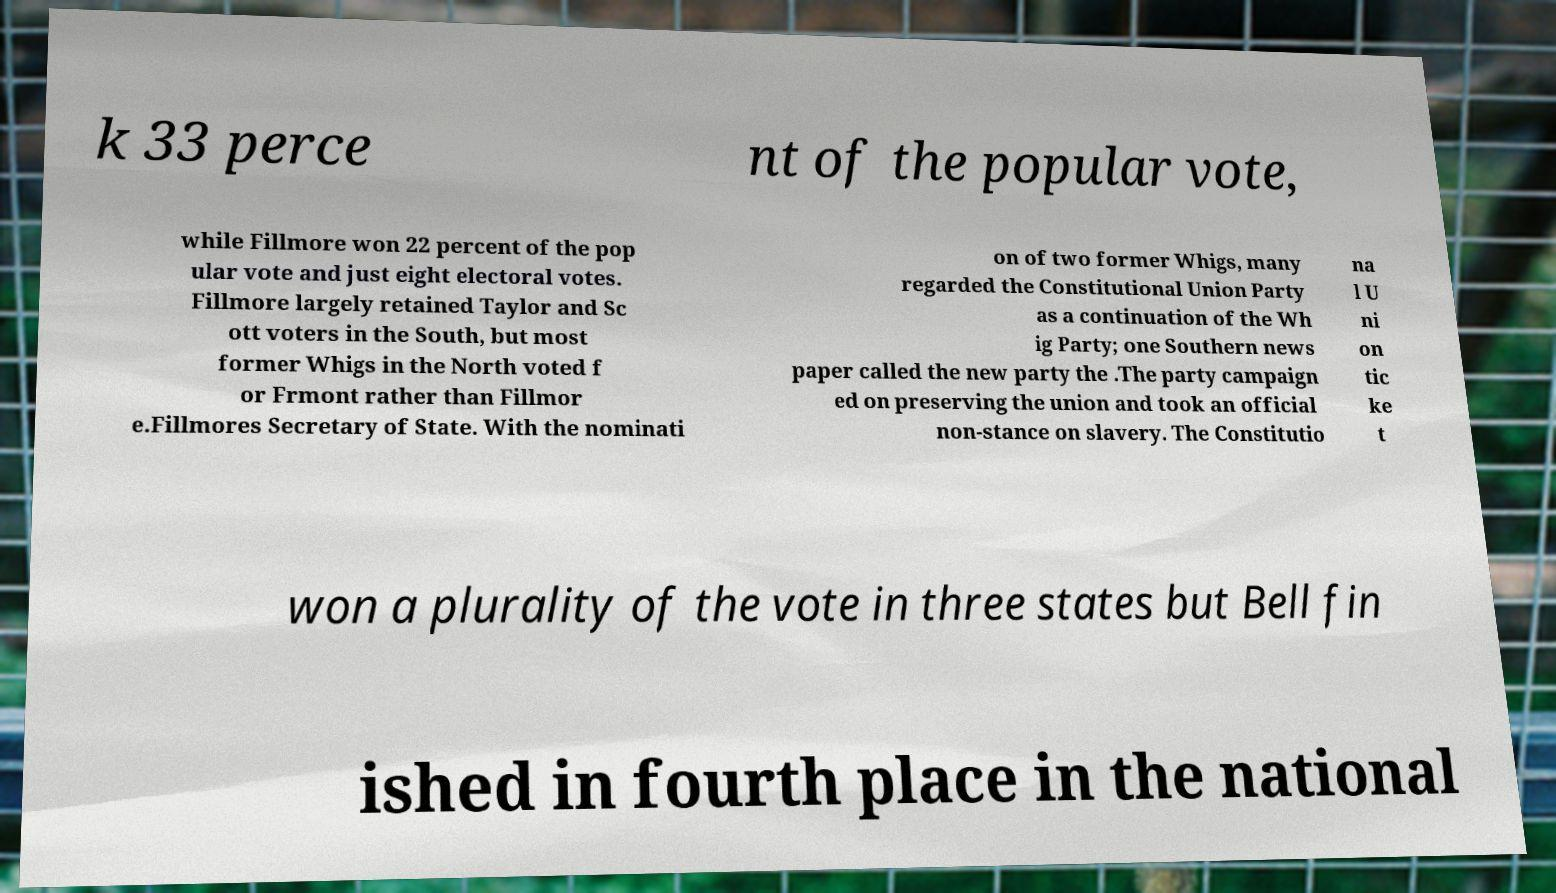Can you accurately transcribe the text from the provided image for me? k 33 perce nt of the popular vote, while Fillmore won 22 percent of the pop ular vote and just eight electoral votes. Fillmore largely retained Taylor and Sc ott voters in the South, but most former Whigs in the North voted f or Frmont rather than Fillmor e.Fillmores Secretary of State. With the nominati on of two former Whigs, many regarded the Constitutional Union Party as a continuation of the Wh ig Party; one Southern news paper called the new party the .The party campaign ed on preserving the union and took an official non-stance on slavery. The Constitutio na l U ni on tic ke t won a plurality of the vote in three states but Bell fin ished in fourth place in the national 